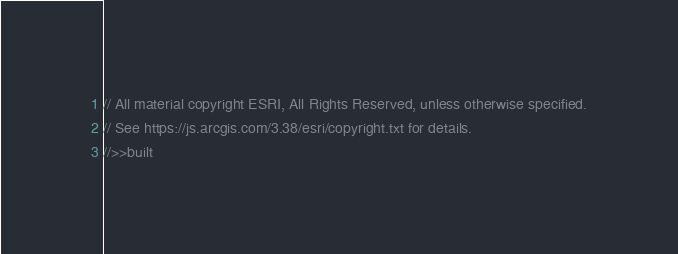Convert code to text. <code><loc_0><loc_0><loc_500><loc_500><_JavaScript_>// All material copyright ESRI, All Rights Reserved, unless otherwise specified.
// See https://js.arcgis.com/3.38/esri/copyright.txt for details.
//>>built</code> 